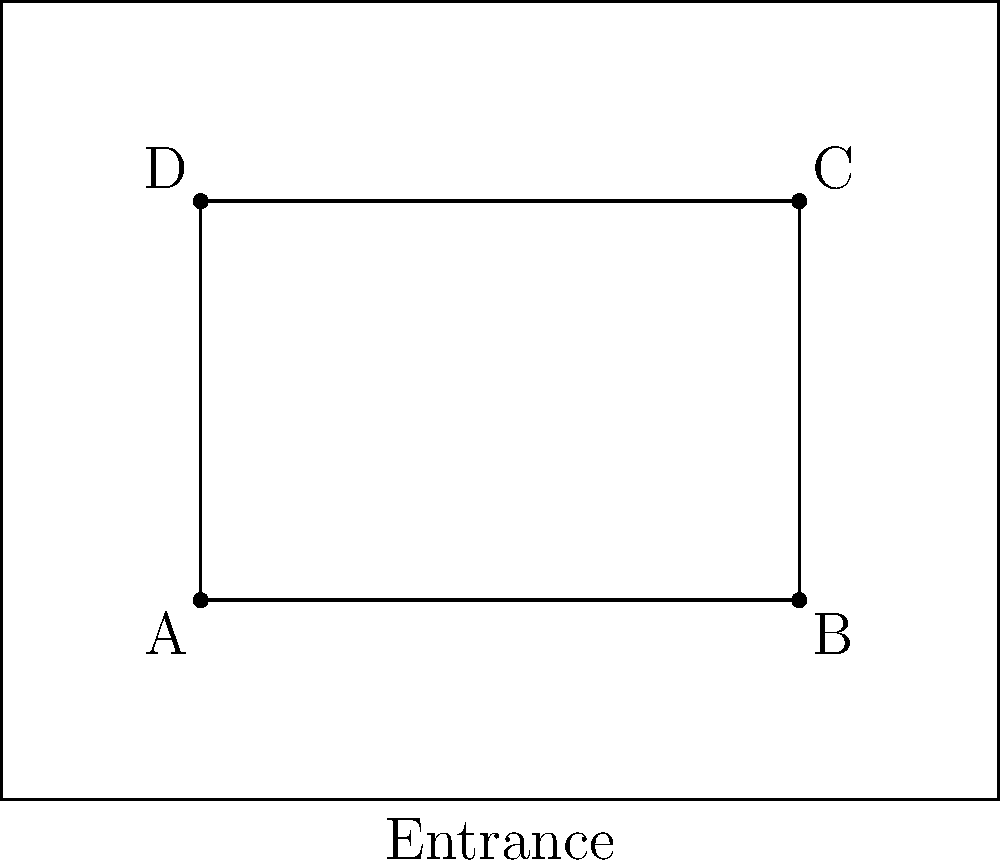In the floor plan of an art gallery where a series of thefts occurred, four stolen paintings were originally positioned at points A, B, C, and D. If the thieves moved in a clockwise direction starting from the entrance, which painting was likely stolen last? Explain your reasoning based on the spatial arrangement and potential psychological factors influencing the criminals' behavior. To analyze the spatial arrangement and determine the likely order of theft, we need to consider several psychological factors:

1. Entry point: The thieves likely entered through the marked entrance at the bottom of the floor plan.

2. Movement pattern: The question states they moved clockwise, which gives us a general direction.

3. Risk assessment: Criminals often start with less risky targets and progress to riskier ones as they gain confidence.

4. Visibility and escape route: Paintings closer to the entrance might be stolen first for a quick escape if needed.

5. Clockwise movement: This suggests a systematic approach, possibly to maintain orientation and reduce the chance of missing valuable items.

Given these factors, we can deduce the probable order of theft:

- Painting A would likely be stolen first due to its proximity to the entrance and being the first encountered in a clockwise direction.
- Painting B would probably be second, following the clockwise movement.
- Painting C would be third, as it's furthest from the entrance and potentially riskier.
- Painting D would likely be stolen last, as it's the final point in the clockwise rotation and furthest from the exit path.

The psychological profile suggests that the thieves would become more daring as they progressed, making the paintings further from the entrance later targets. Painting D, being the last in the clockwise rotation and furthest from the entrance, aligns with this profile as the final target.
Answer: Painting D 